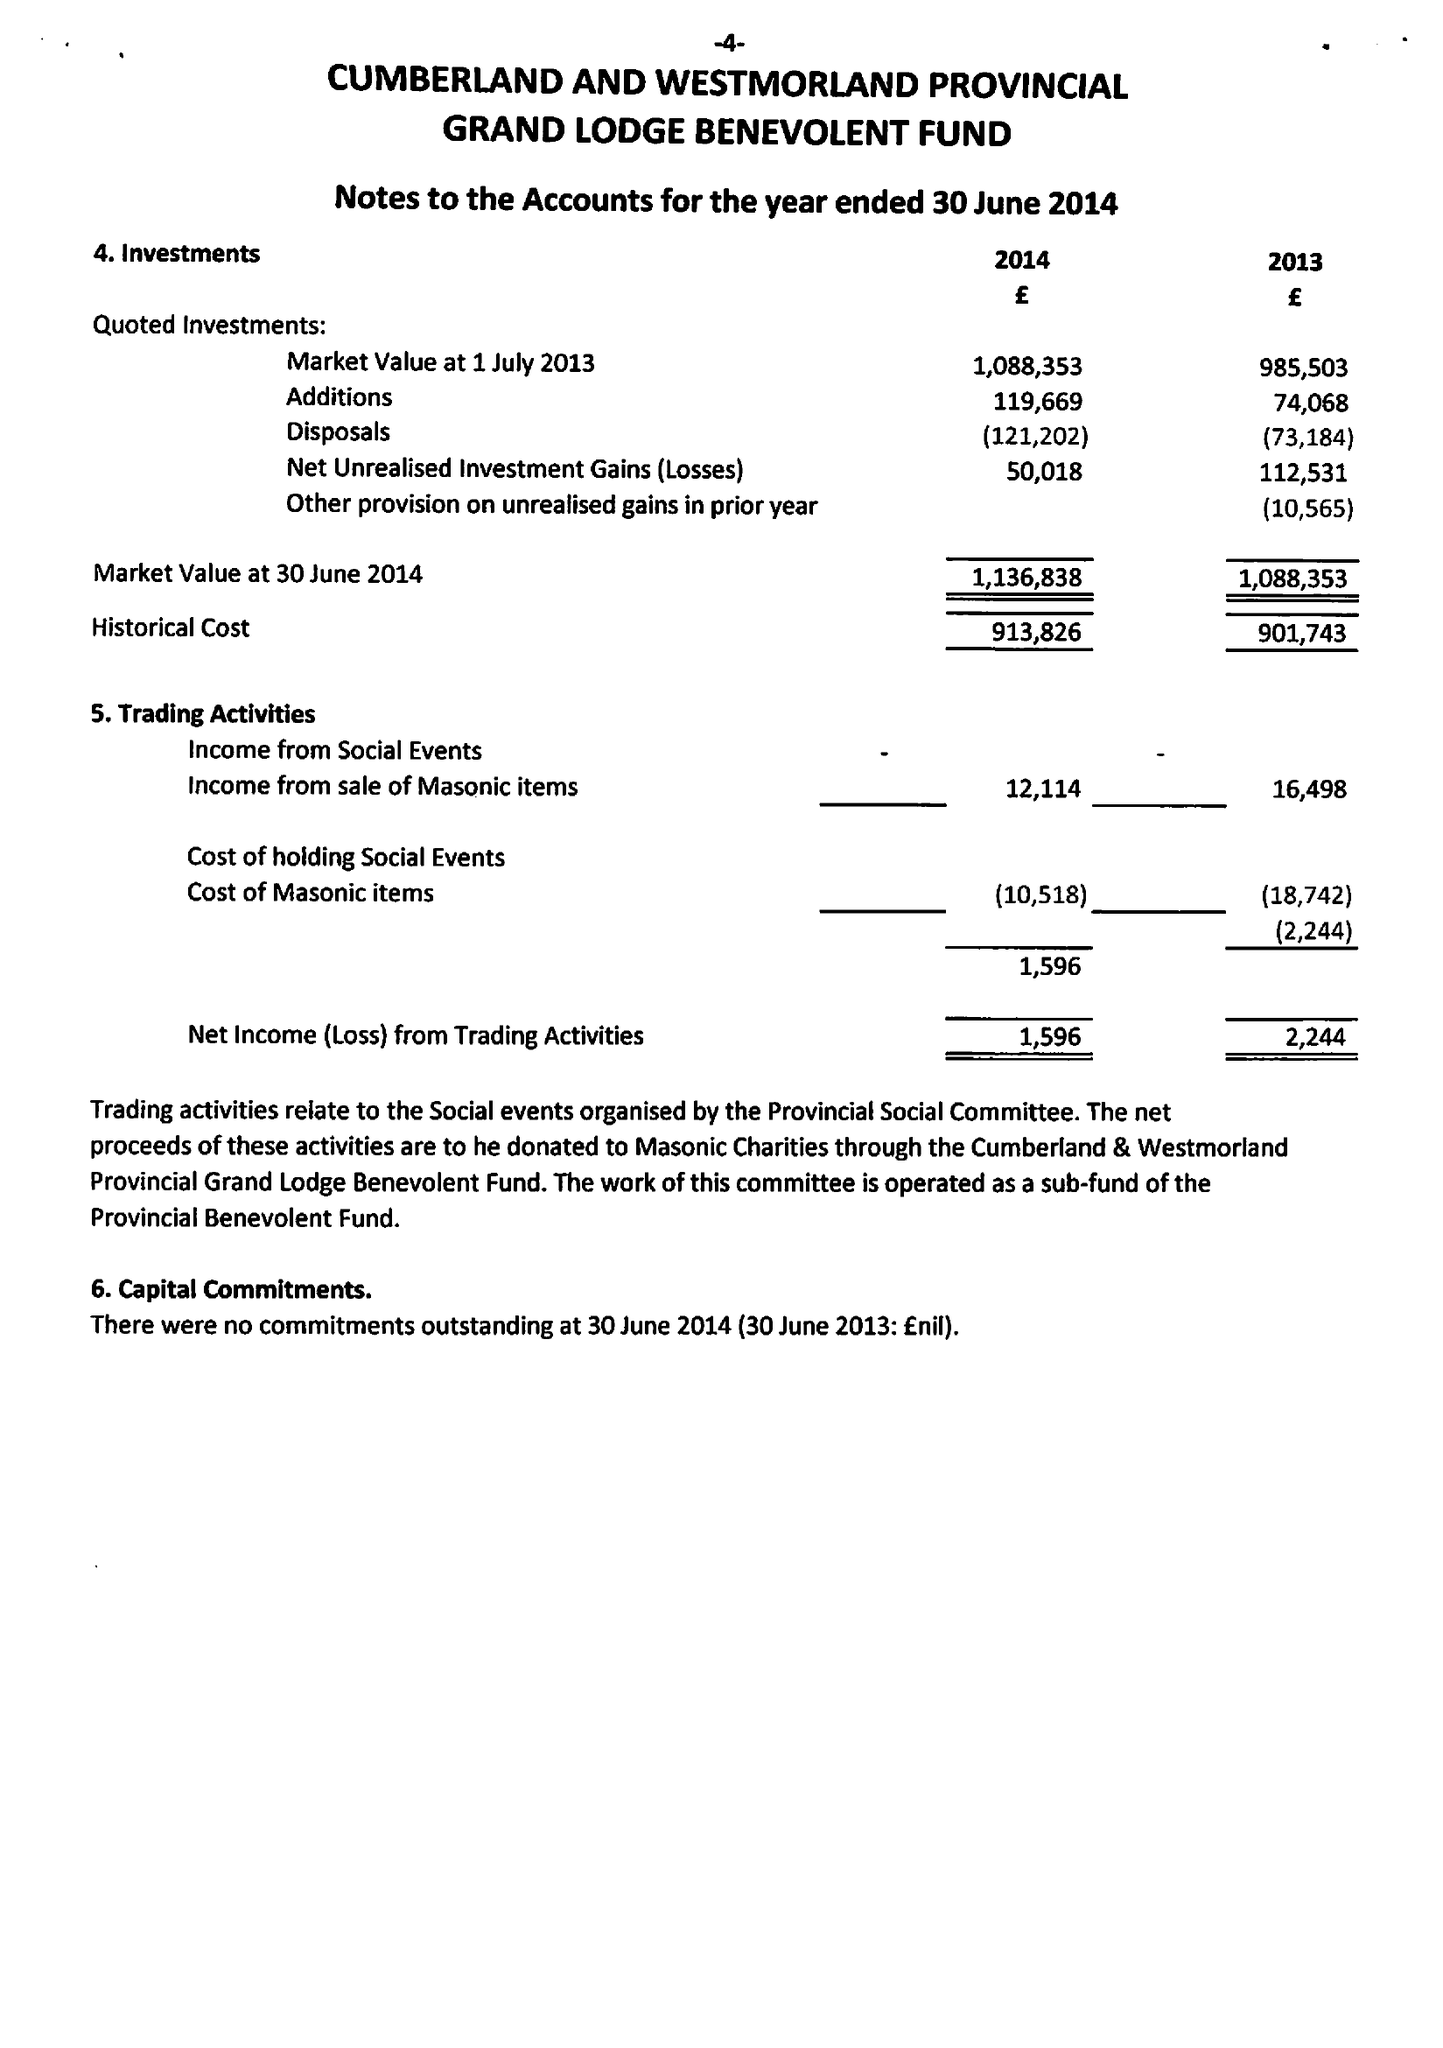What is the value for the charity_number?
Answer the question using a single word or phrase. 213203 